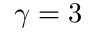<formula> <loc_0><loc_0><loc_500><loc_500>\gamma = 3</formula> 